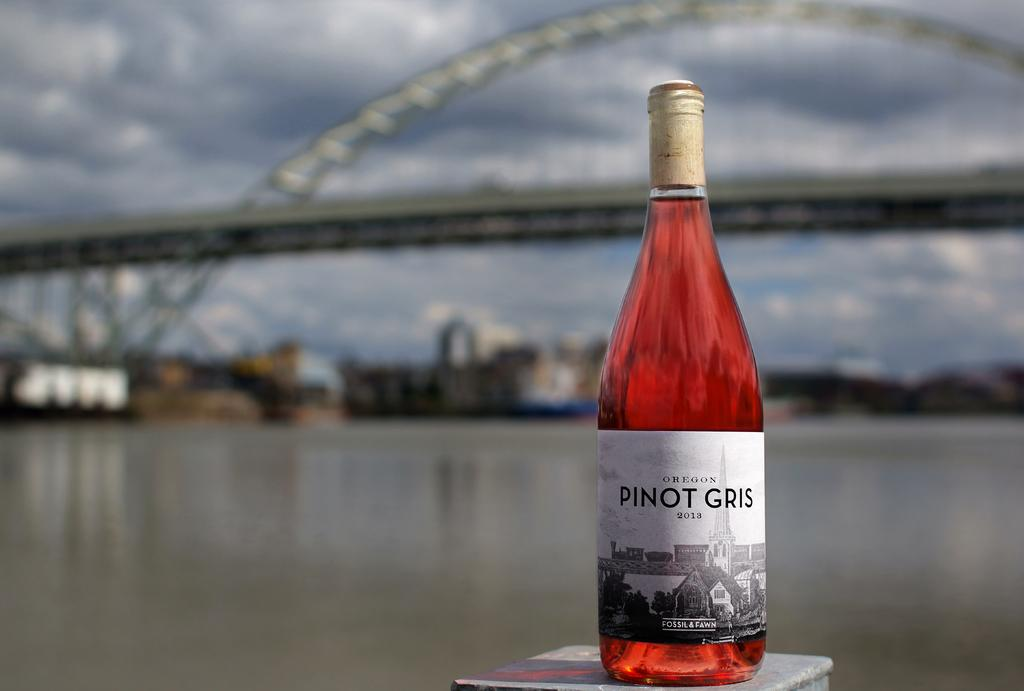<image>
Summarize the visual content of the image. Bottle of wine which has a label that says PINOT GRIS. 